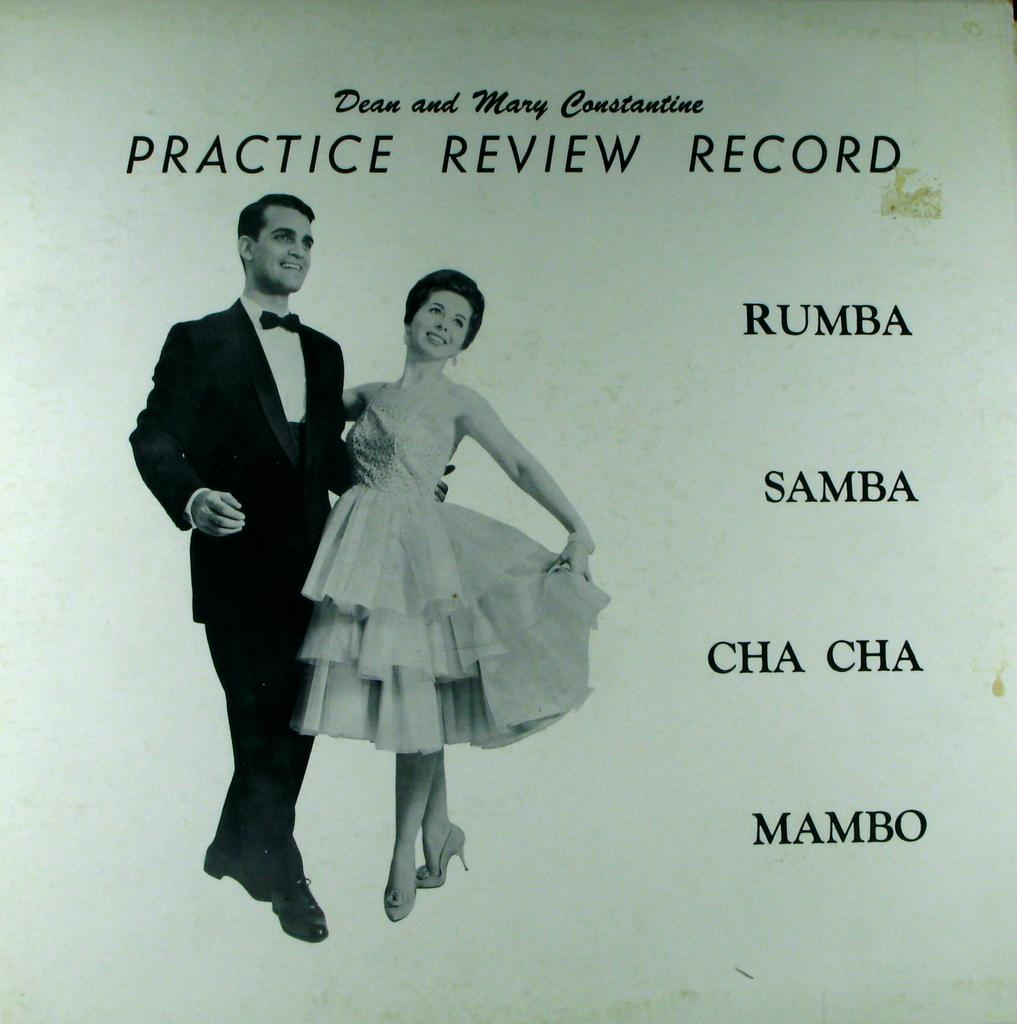What is depicted in the picture on the poster? The poster contains a picture of a person and a woman. What are the positions of the person and the woman in the picture? The person is standing, and the woman is standing. What is written beside the picture on the poster? There is text beside the picture on the poster. What are the person and the woman wearing in the picture? The person is wearing a suit and tie, and the woman is wearing a dress. What type of loaf is being used as an example in the picture? There is no loaf present in the picture; it features a person and a woman. What season is depicted in the picture? The provided facts do not mention any season or weather-related details, so it cannot be determined from the image. 